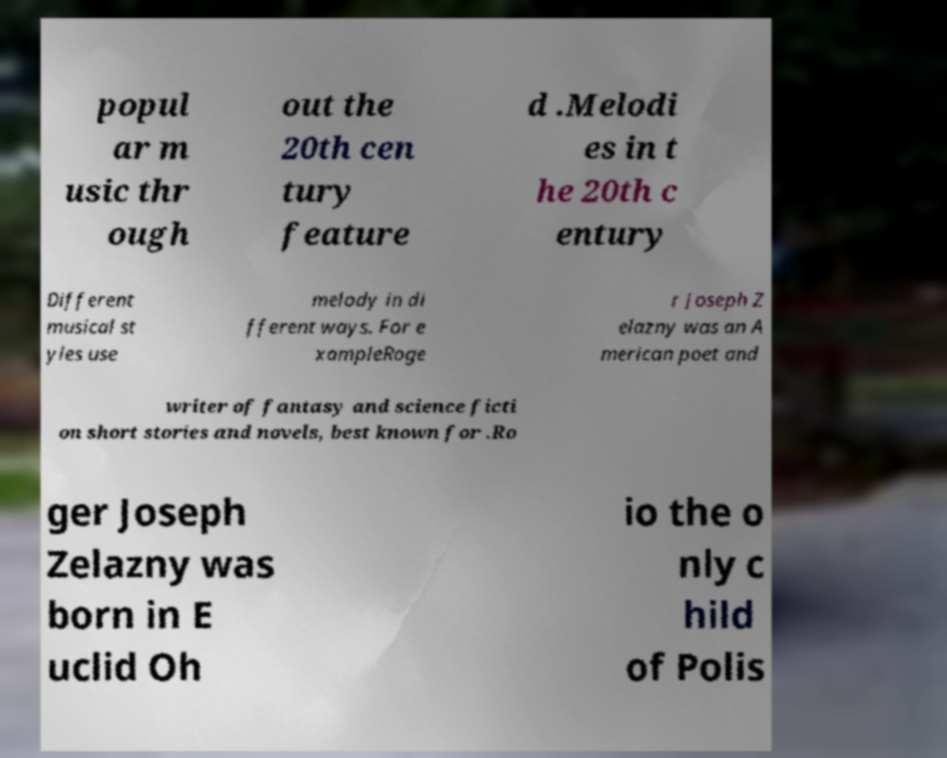Can you accurately transcribe the text from the provided image for me? popul ar m usic thr ough out the 20th cen tury feature d .Melodi es in t he 20th c entury Different musical st yles use melody in di fferent ways. For e xampleRoge r Joseph Z elazny was an A merican poet and writer of fantasy and science ficti on short stories and novels, best known for .Ro ger Joseph Zelazny was born in E uclid Oh io the o nly c hild of Polis 